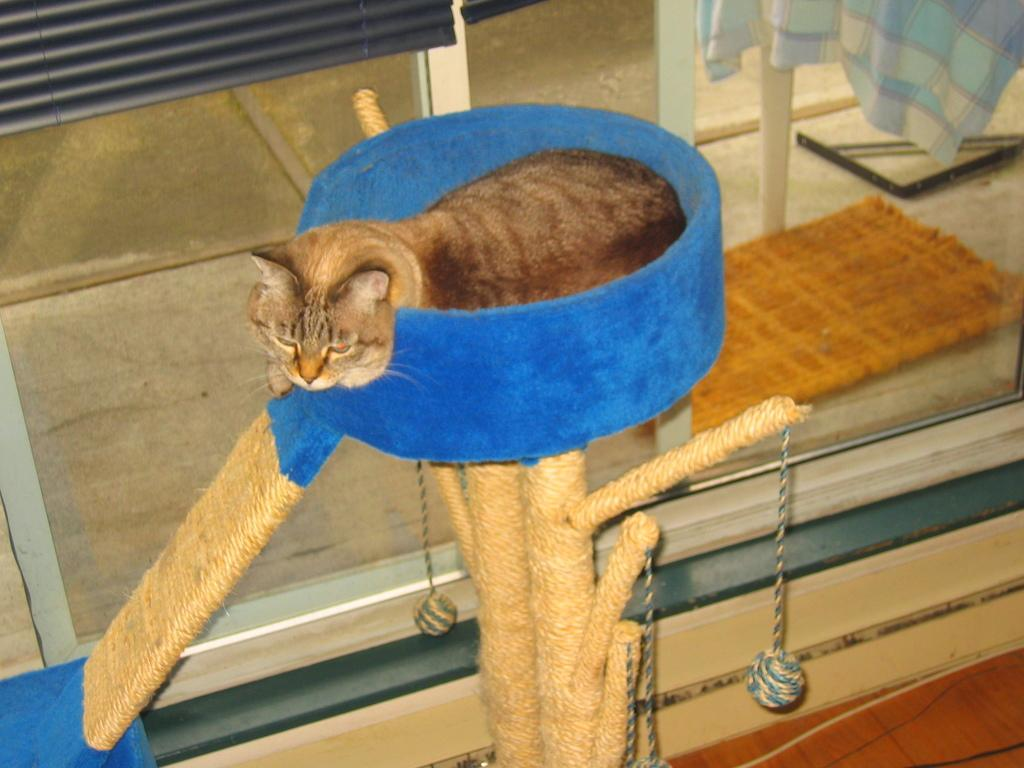What is the main subject in the center of the image? There is a cat in the center of the image. What can be seen in the background of the image? There is a glass door in the background of the image. What type of flooring is visible at the bottom of the image? There is wooden flooring at the bottom of the image. Is there a stream of water flowing through the cat's fur in the image? No, there is no stream of water present in the image. 